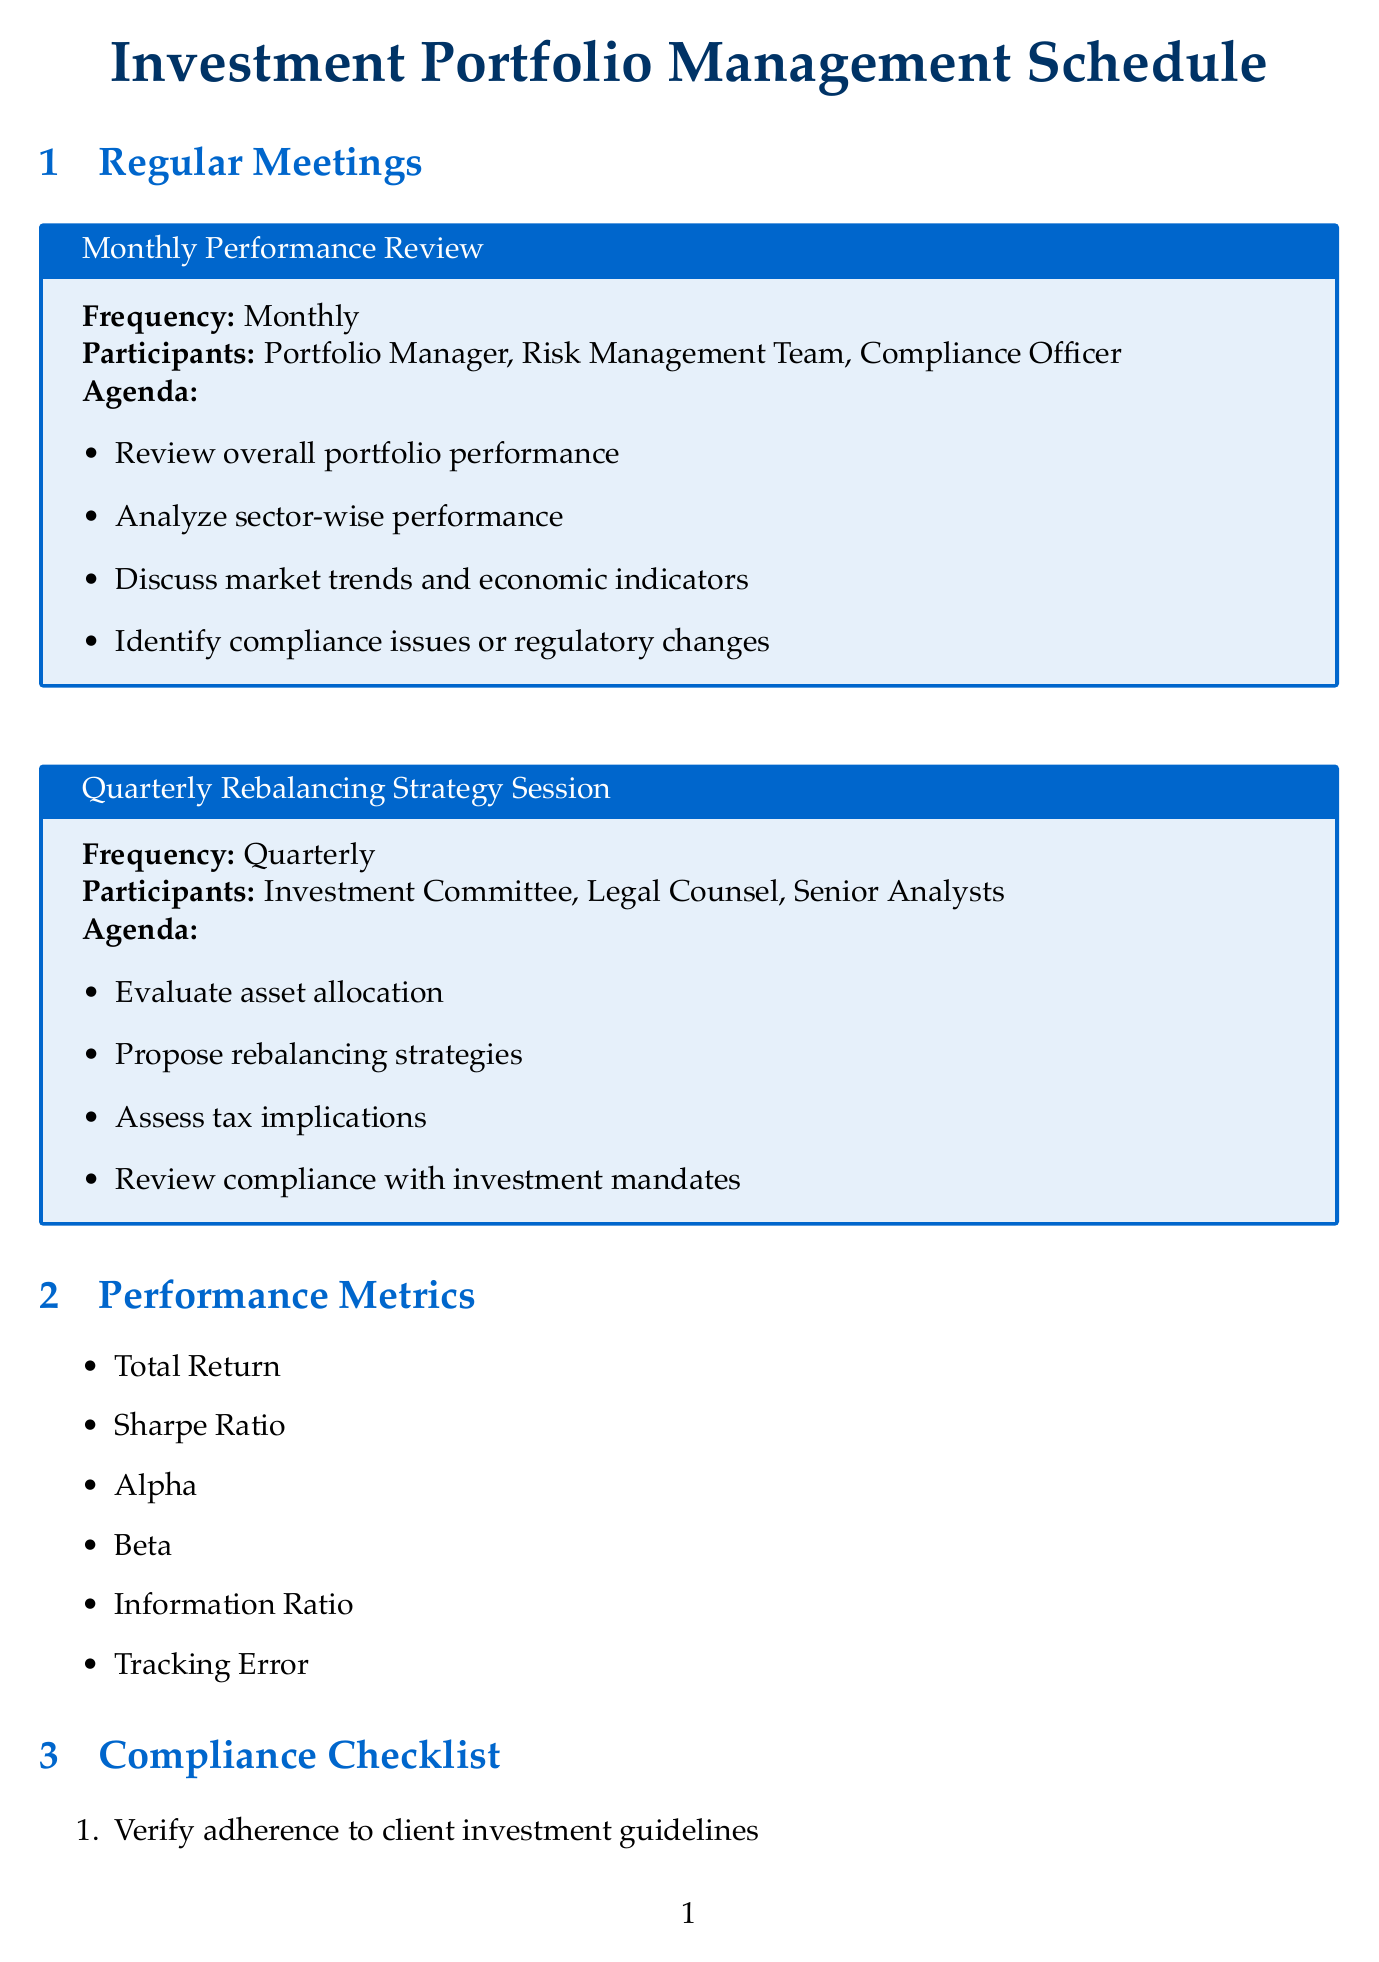What is the frequency of the Monthly Performance Review? The frequency of the Monthly Performance Review is explicitly stated in the document.
Answer: Monthly Who participates in the Quarterly Rebalancing Strategy Session? The participants are listed in the document under the agenda for the Quarterly Rebalancing Strategy Session.
Answer: Investment Committee, Legal Counsel, Senior Analysts What is the first step in the rebalancing process? The document outlines the steps in the rebalancing process in sequence.
Answer: Data Collection Which performance metrics are included? The document contains a list of performance metrics mentioned.
Answer: Total Return, Sharpe Ratio, Alpha, Beta, Information Ratio, Tracking Error What regulatory consideration pertains to derivative transactions? The document explicitly links the Dodd-Frank Act to derivative transactions.
Answer: Dodd-Frank Act What type of report is sent to clients monthly? The document states the recipient and content of monthly reports in the reporting requirements section.
Answer: Monthly Performance Summary How often is the Compliance Attestation report generated? The frequency of the Quarterly Compliance Attestation can be inferred from the schedule of meetings.
Answer: Quarterly Who is responsible for the Legal and Compliance Review step? The responsible party for each rebalancing step is outlined in the document.
Answer: Legal and Compliance Department What is discussed in the agenda of the Monthly Performance Review? The agenda items are provided explicitly in the document for the Monthly Performance Review.
Answer: Review overall portfolio performance, Analyze sector-wise performance, Discuss market trends and economic indicators, Identify compliance issues or regulatory changes 